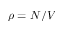Convert formula to latex. <formula><loc_0><loc_0><loc_500><loc_500>\rho = N / V</formula> 